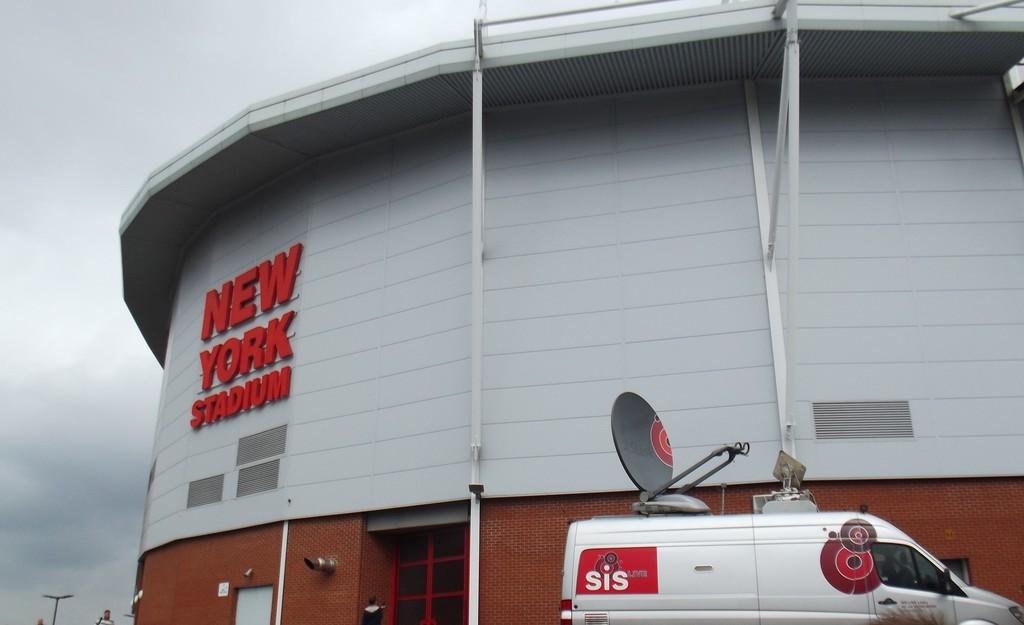What city is the stadium in?
Ensure brevity in your answer.  New york. What are the letters on the side of the white van?
Provide a short and direct response. Sis. 